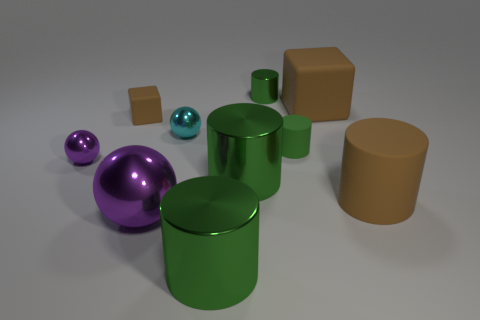There is a cylinder that is behind the brown rubber object on the left side of the small green metal cylinder; what is its color?
Offer a very short reply. Green. There is a brown rubber thing that is the same shape as the green matte object; what is its size?
Ensure brevity in your answer.  Large. Does the tiny matte block have the same color as the big rubber cube?
Offer a terse response. Yes. What number of green cylinders are in front of the small rubber object that is to the right of the metallic cylinder behind the cyan metal ball?
Provide a short and direct response. 2. Are there more green objects than tiny red objects?
Ensure brevity in your answer.  Yes. What number of large brown matte cylinders are there?
Provide a short and direct response. 1. The small thing that is in front of the tiny thing right of the metallic cylinder behind the small green matte cylinder is what shape?
Your response must be concise. Sphere. Are there fewer big brown things behind the small green metallic object than shiny cylinders in front of the cyan metal thing?
Keep it short and to the point. Yes. Does the big thing that is in front of the big metal sphere have the same shape as the green shiny object that is behind the small purple ball?
Keep it short and to the point. Yes. What is the shape of the large green thing in front of the large brown matte cylinder in front of the green matte cylinder?
Your answer should be very brief. Cylinder. 